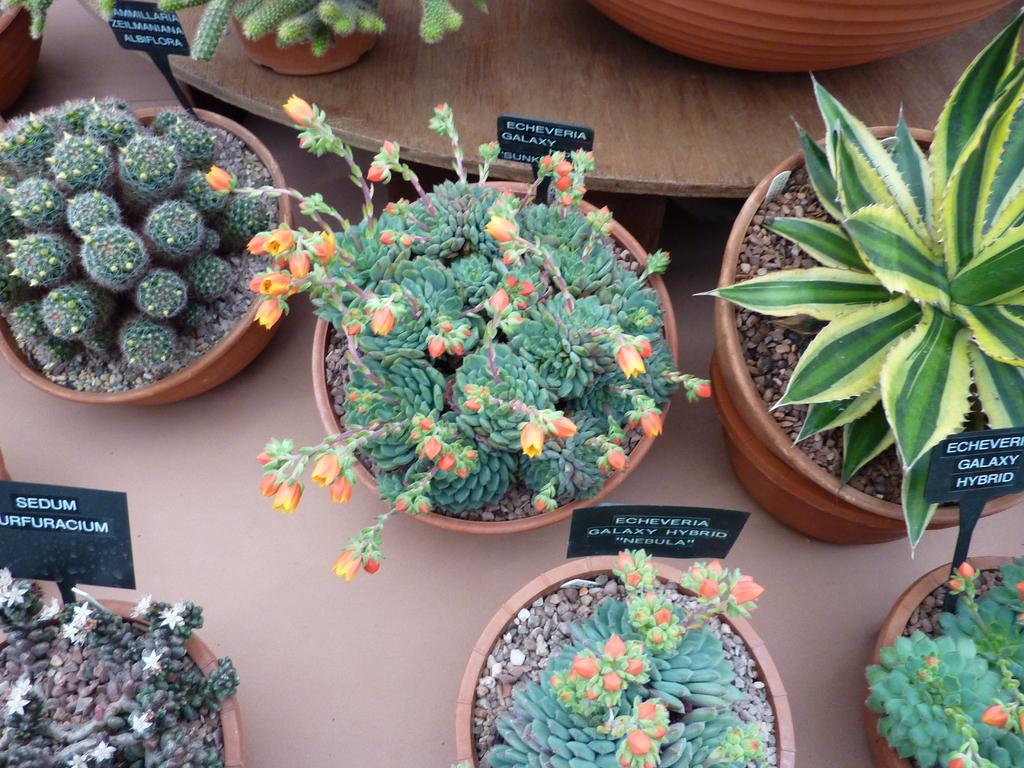What type of objects can be seen in the image? There are flower pots in the image. Where are the flower pots located? The flower pots are on a surface. What other feature is present in the image? There is a wooden platform in the image. Can you describe the wooden platform? The wooden platform has names on it. What type of curtain can be seen hanging from the shelf in the image? There is no curtain or shelf present in the image. 